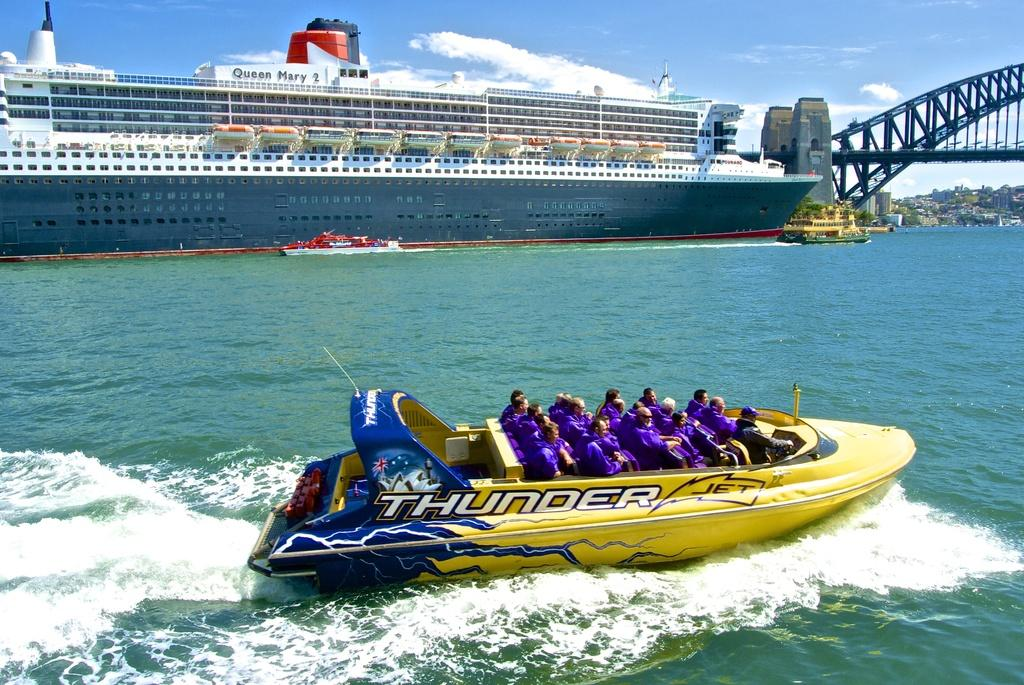<image>
Provide a brief description of the given image. A group of people in purple shirts riding in a Thunder Jet boat. 